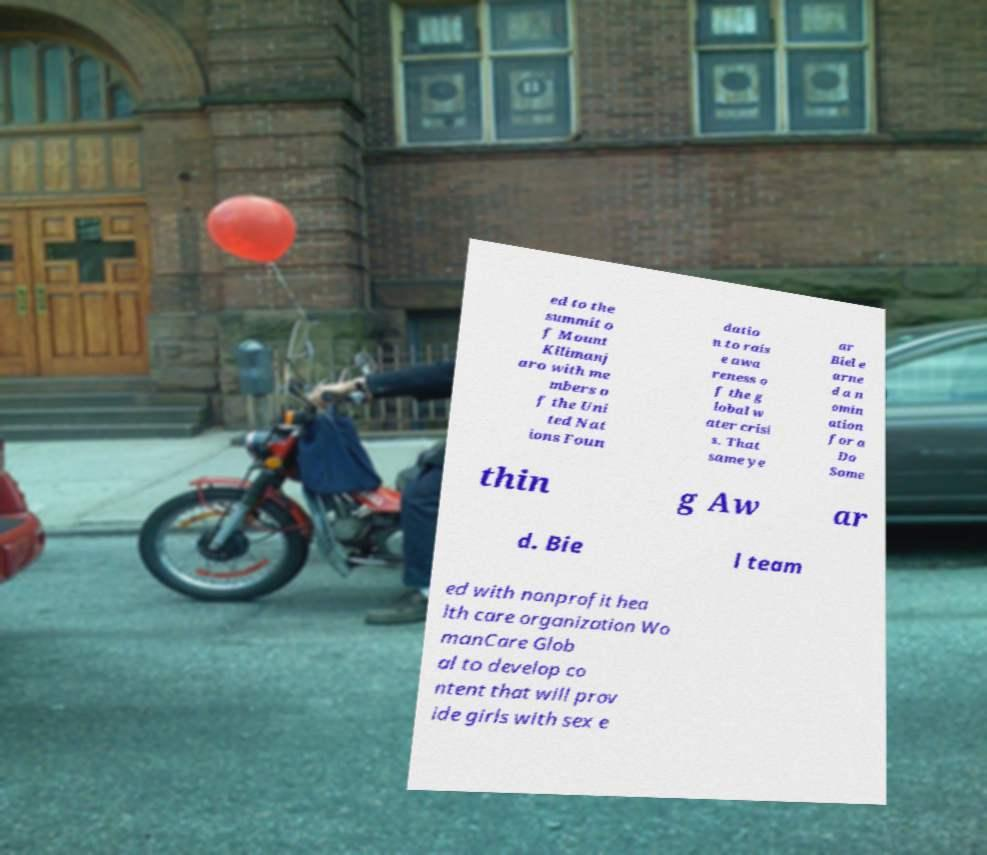Please read and relay the text visible in this image. What does it say? ed to the summit o f Mount Kilimanj aro with me mbers o f the Uni ted Nat ions Foun datio n to rais e awa reness o f the g lobal w ater crisi s. That same ye ar Biel e arne d a n omin ation for a Do Some thin g Aw ar d. Bie l team ed with nonprofit hea lth care organization Wo manCare Glob al to develop co ntent that will prov ide girls with sex e 